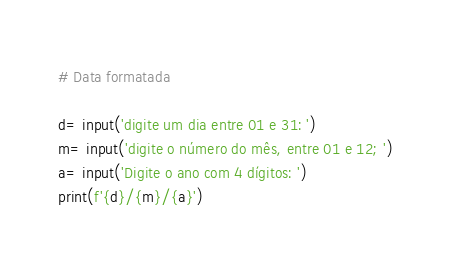<code> <loc_0><loc_0><loc_500><loc_500><_Python_># Data formatada

d= input('digite um dia entre 01 e 31: ')
m= input('digite o número do mês, entre 01 e 12; ')
a= input('Digite o ano com 4 dígitos: ')
print(f'{d}/{m}/{a}')</code> 